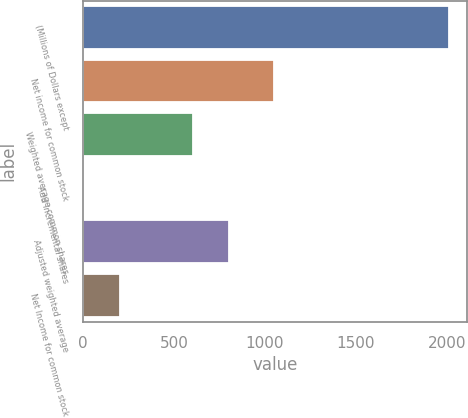<chart> <loc_0><loc_0><loc_500><loc_500><bar_chart><fcel>(Millions of Dollars except<fcel>Net income for common stock<fcel>Weighted average common shares<fcel>Add Incremental shares<fcel>Adjusted weighted average<fcel>Net Income for common stock<nl><fcel>2011<fcel>1051<fcel>604.56<fcel>1.8<fcel>805.48<fcel>202.72<nl></chart> 